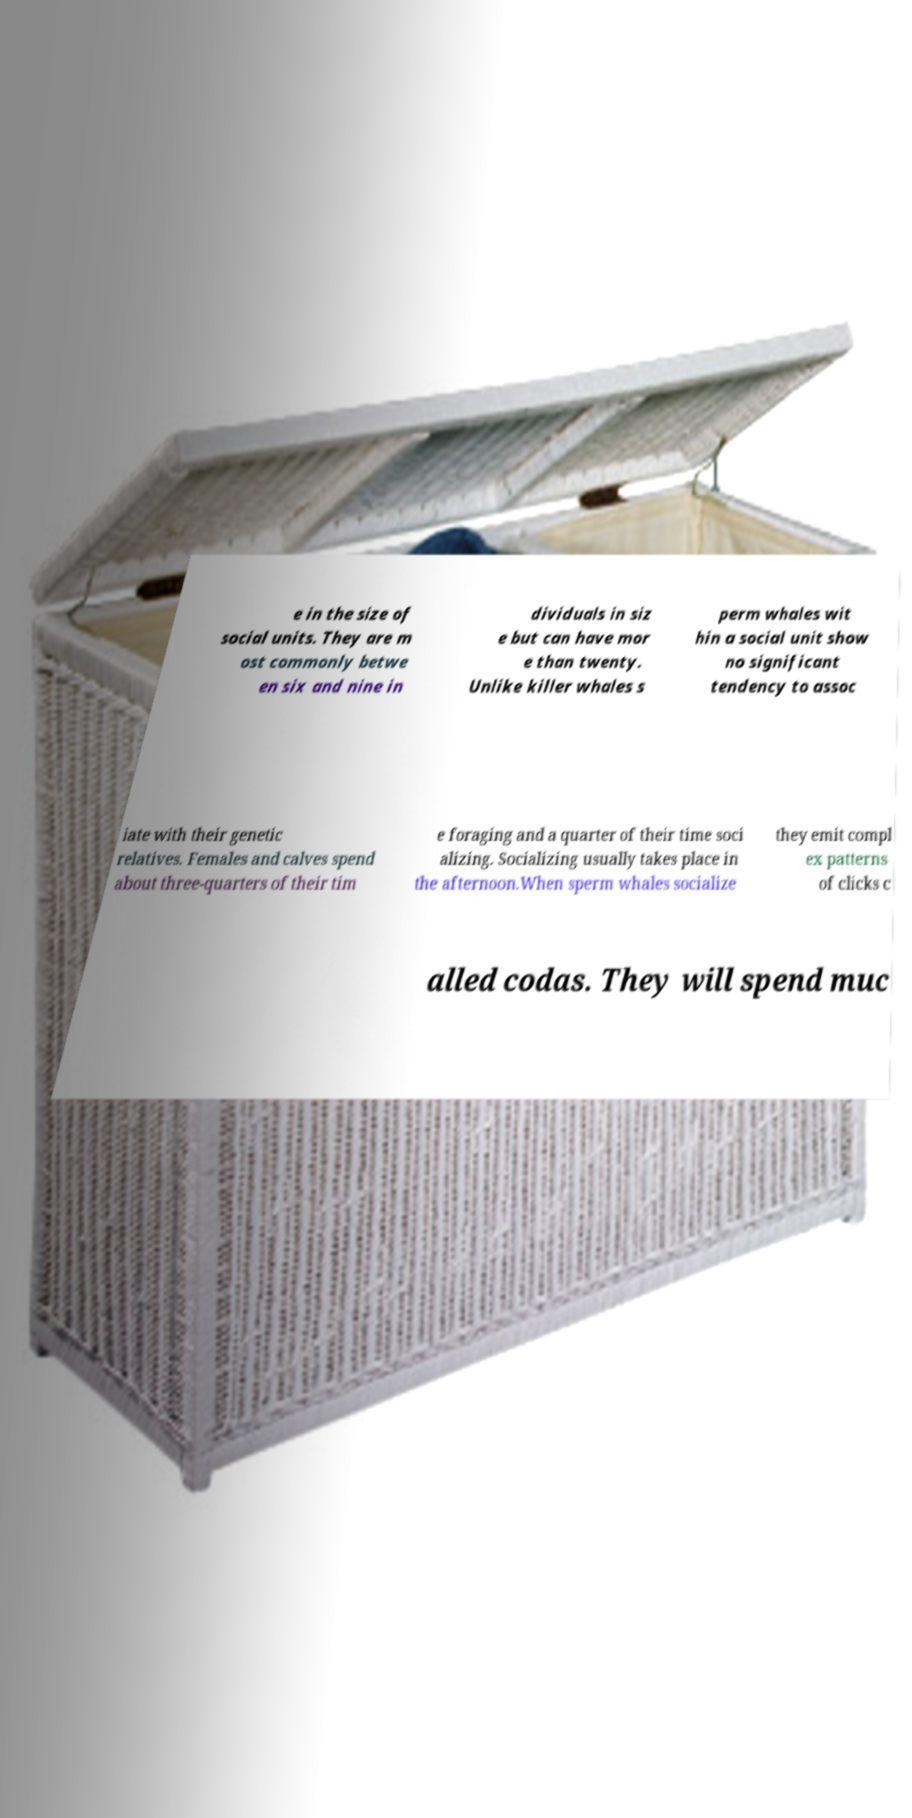Could you extract and type out the text from this image? e in the size of social units. They are m ost commonly betwe en six and nine in dividuals in siz e but can have mor e than twenty. Unlike killer whales s perm whales wit hin a social unit show no significant tendency to assoc iate with their genetic relatives. Females and calves spend about three-quarters of their tim e foraging and a quarter of their time soci alizing. Socializing usually takes place in the afternoon.When sperm whales socialize they emit compl ex patterns of clicks c alled codas. They will spend muc 